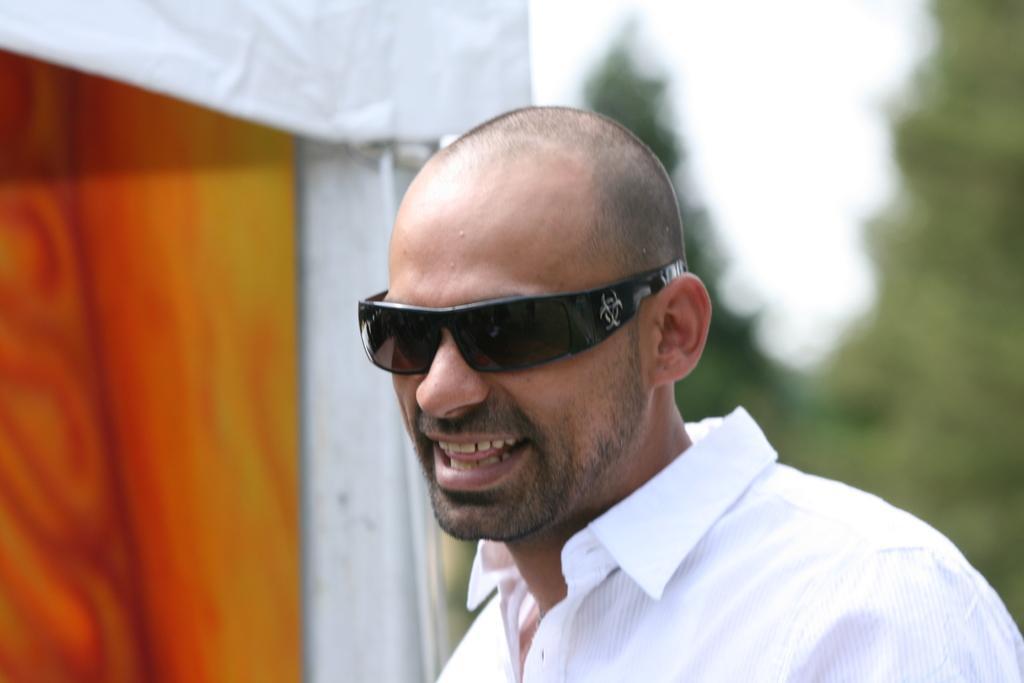How would you summarize this image in a sentence or two? In the image there is a man in the foreground, he is wearing goggles and laughing, the background of the man is blur. 